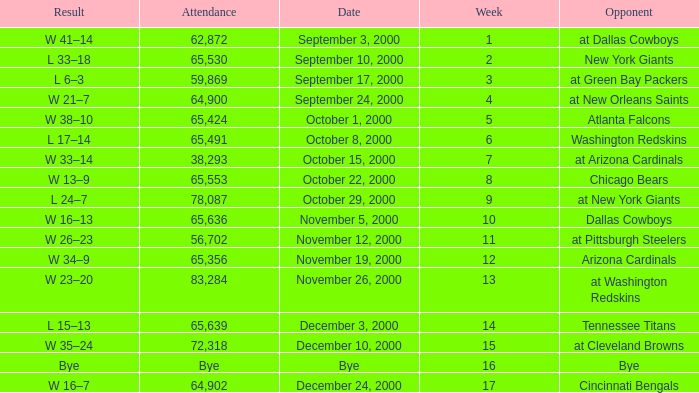What was the attendance when the Cincinnati Bengals were the opponents? 64902.0. 